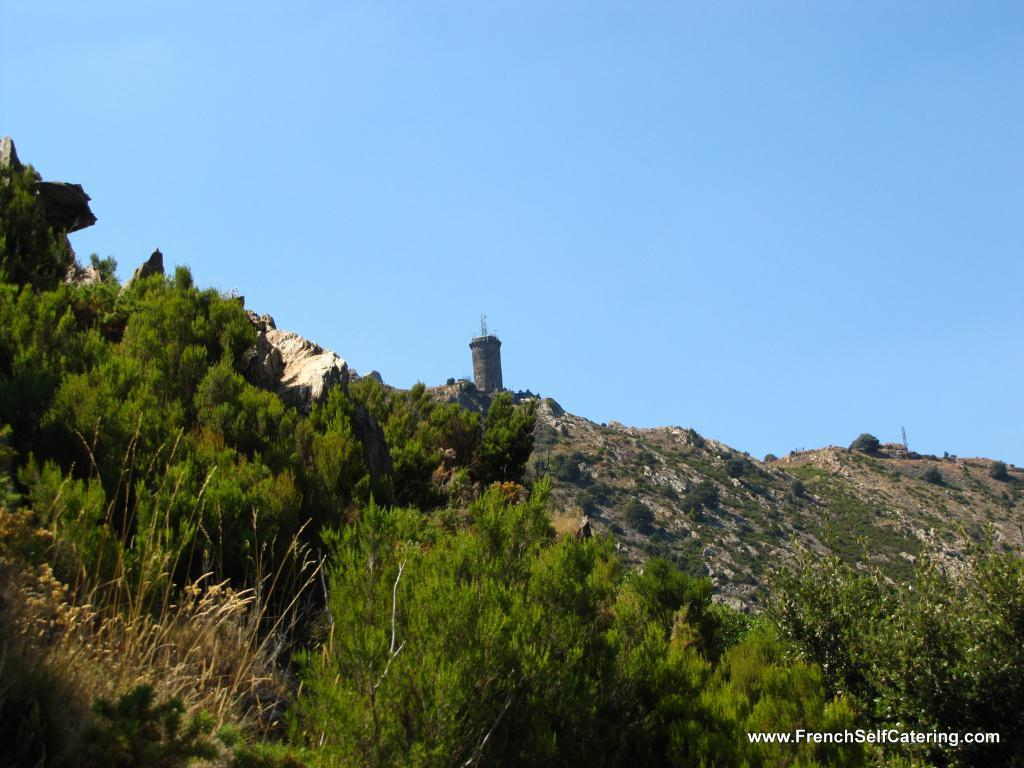What type of vegetation can be seen in the image? There are trees in the image. What else can be seen on the ground in the image? There is grass in the image. What geographical feature is present in the image? There is a mountain in the image. Is there any structure on the mountain? Yes, there is a pillar on the mountain. What is visible in the background of the image? The sky is visible in the background of the image. Can you see the face of the person who gave birth in the image? There is no person or reference to birth in the image; it features trees, grass, a mountain, and a pillar. Is there an ocean visible in the image? There is no ocean present in the image; it features trees, grass, a mountain, and a pillar. 